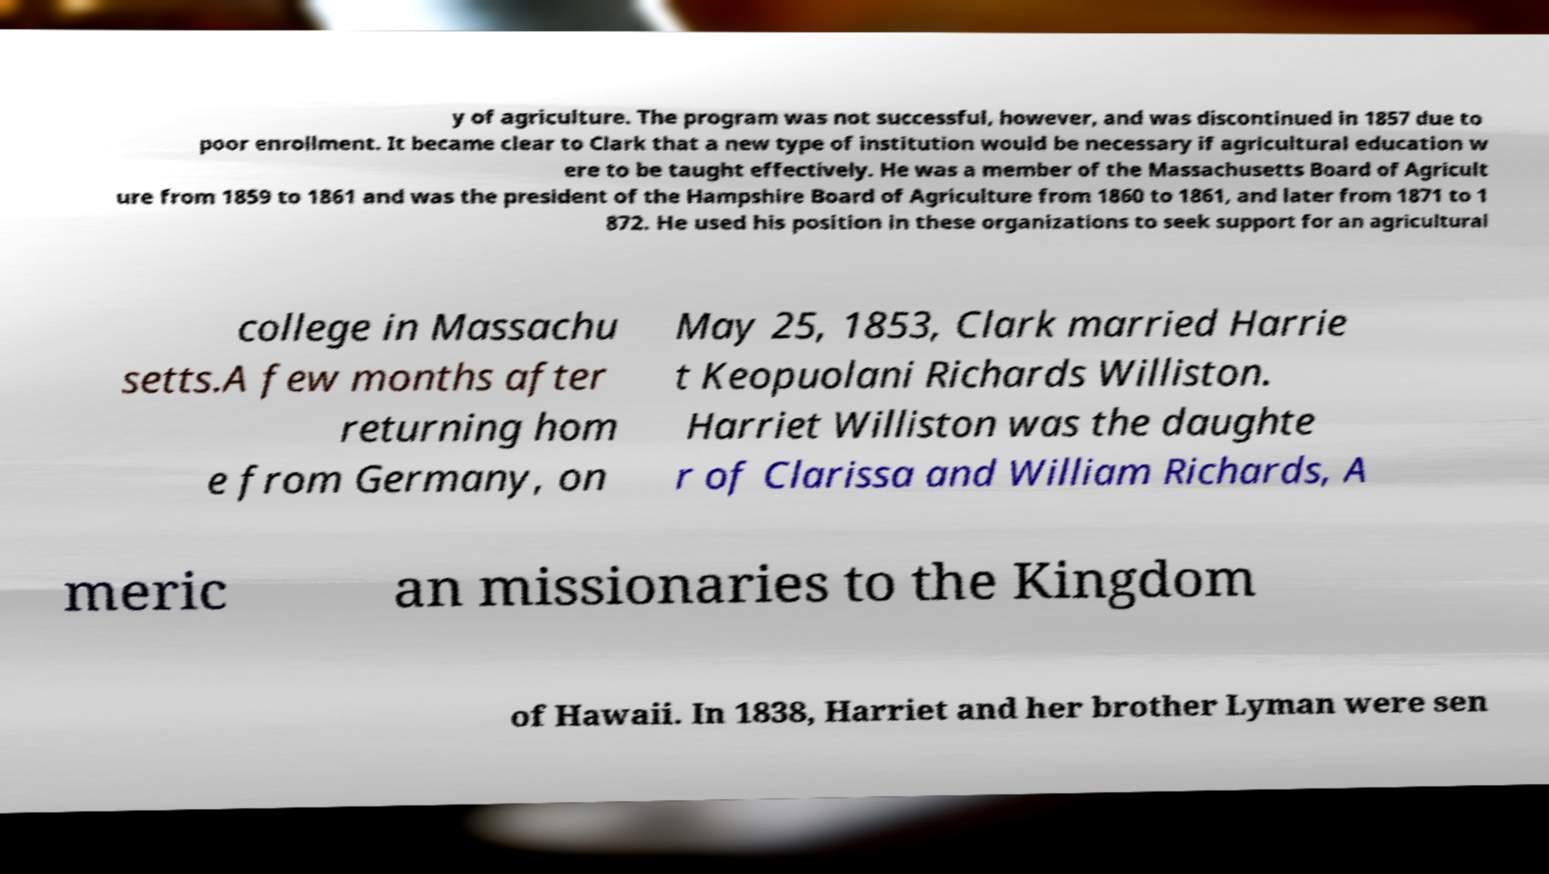Could you extract and type out the text from this image? y of agriculture. The program was not successful, however, and was discontinued in 1857 due to poor enrollment. It became clear to Clark that a new type of institution would be necessary if agricultural education w ere to be taught effectively. He was a member of the Massachusetts Board of Agricult ure from 1859 to 1861 and was the president of the Hampshire Board of Agriculture from 1860 to 1861, and later from 1871 to 1 872. He used his position in these organizations to seek support for an agricultural college in Massachu setts.A few months after returning hom e from Germany, on May 25, 1853, Clark married Harrie t Keopuolani Richards Williston. Harriet Williston was the daughte r of Clarissa and William Richards, A meric an missionaries to the Kingdom of Hawaii. In 1838, Harriet and her brother Lyman were sen 